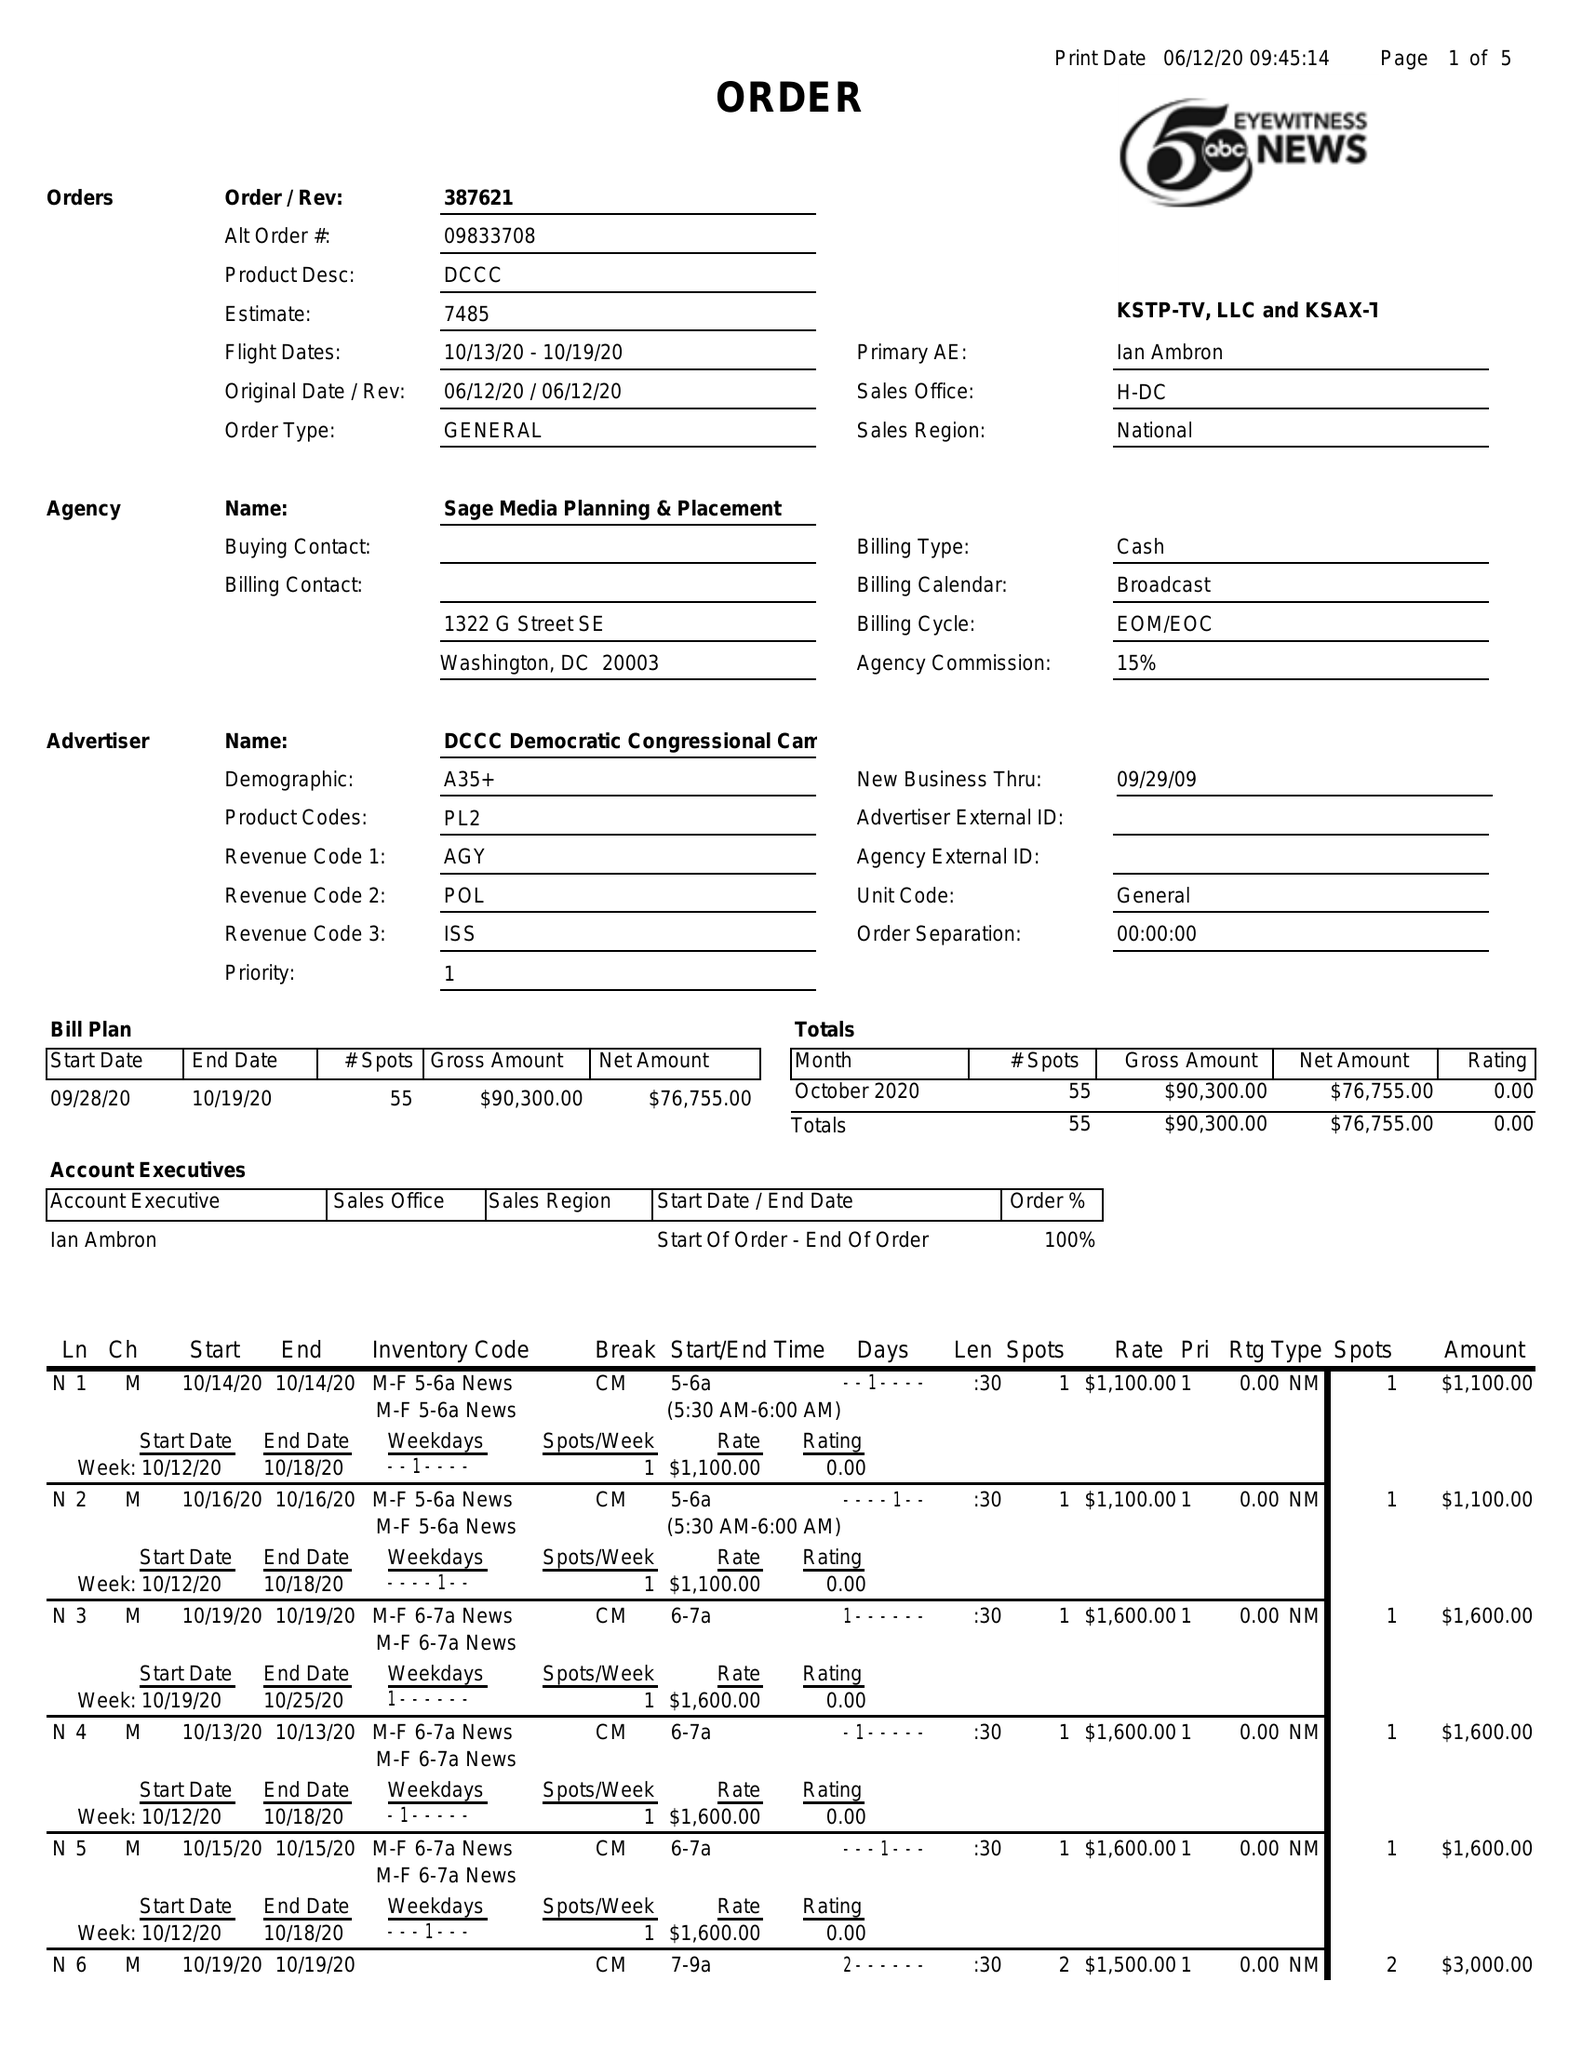What is the value for the flight_from?
Answer the question using a single word or phrase. 10/13/20 